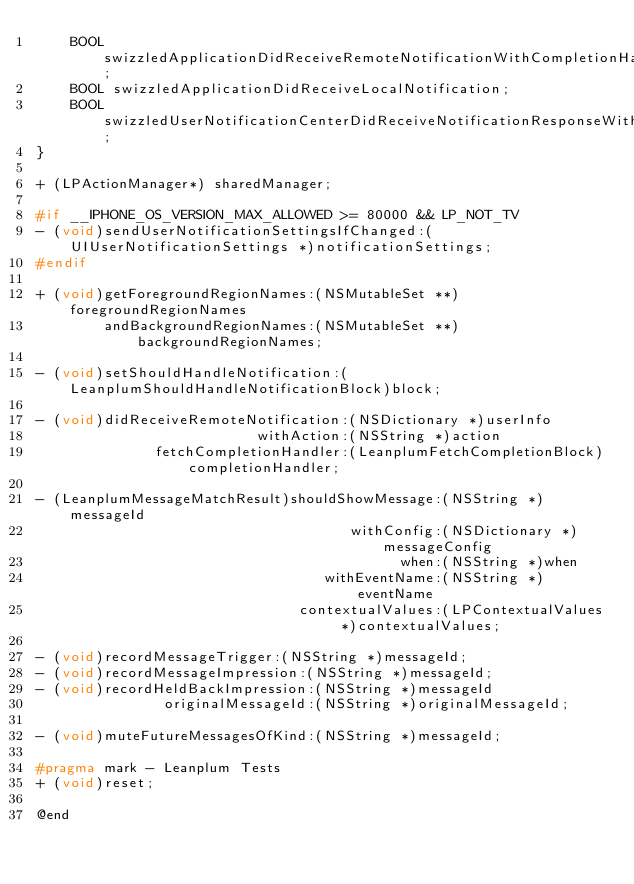<code> <loc_0><loc_0><loc_500><loc_500><_C_>    BOOL swizzledApplicationDidReceiveRemoteNotificationWithCompletionHandler;
    BOOL swizzledApplicationDidReceiveLocalNotification;
    BOOL swizzledUserNotificationCenterDidReceiveNotificationResponseWithCompletionHandler;
}

+ (LPActionManager*) sharedManager;

#if __IPHONE_OS_VERSION_MAX_ALLOWED >= 80000 && LP_NOT_TV
- (void)sendUserNotificationSettingsIfChanged:(UIUserNotificationSettings *)notificationSettings;
#endif

+ (void)getForegroundRegionNames:(NSMutableSet **)foregroundRegionNames
        andBackgroundRegionNames:(NSMutableSet **)backgroundRegionNames;

- (void)setShouldHandleNotification:(LeanplumShouldHandleNotificationBlock)block;

- (void)didReceiveRemoteNotification:(NSDictionary *)userInfo
                          withAction:(NSString *)action
              fetchCompletionHandler:(LeanplumFetchCompletionBlock)completionHandler;

- (LeanplumMessageMatchResult)shouldShowMessage:(NSString *)messageId
                                     withConfig:(NSDictionary *)messageConfig
                                           when:(NSString *)when
                                  withEventName:(NSString *)eventName
                               contextualValues:(LPContextualValues *)contextualValues;

- (void)recordMessageTrigger:(NSString *)messageId;
- (void)recordMessageImpression:(NSString *)messageId;
- (void)recordHeldBackImpression:(NSString *)messageId
               originalMessageId:(NSString *)originalMessageId;

- (void)muteFutureMessagesOfKind:(NSString *)messageId;

#pragma mark - Leanplum Tests
+ (void)reset;

@end
</code> 